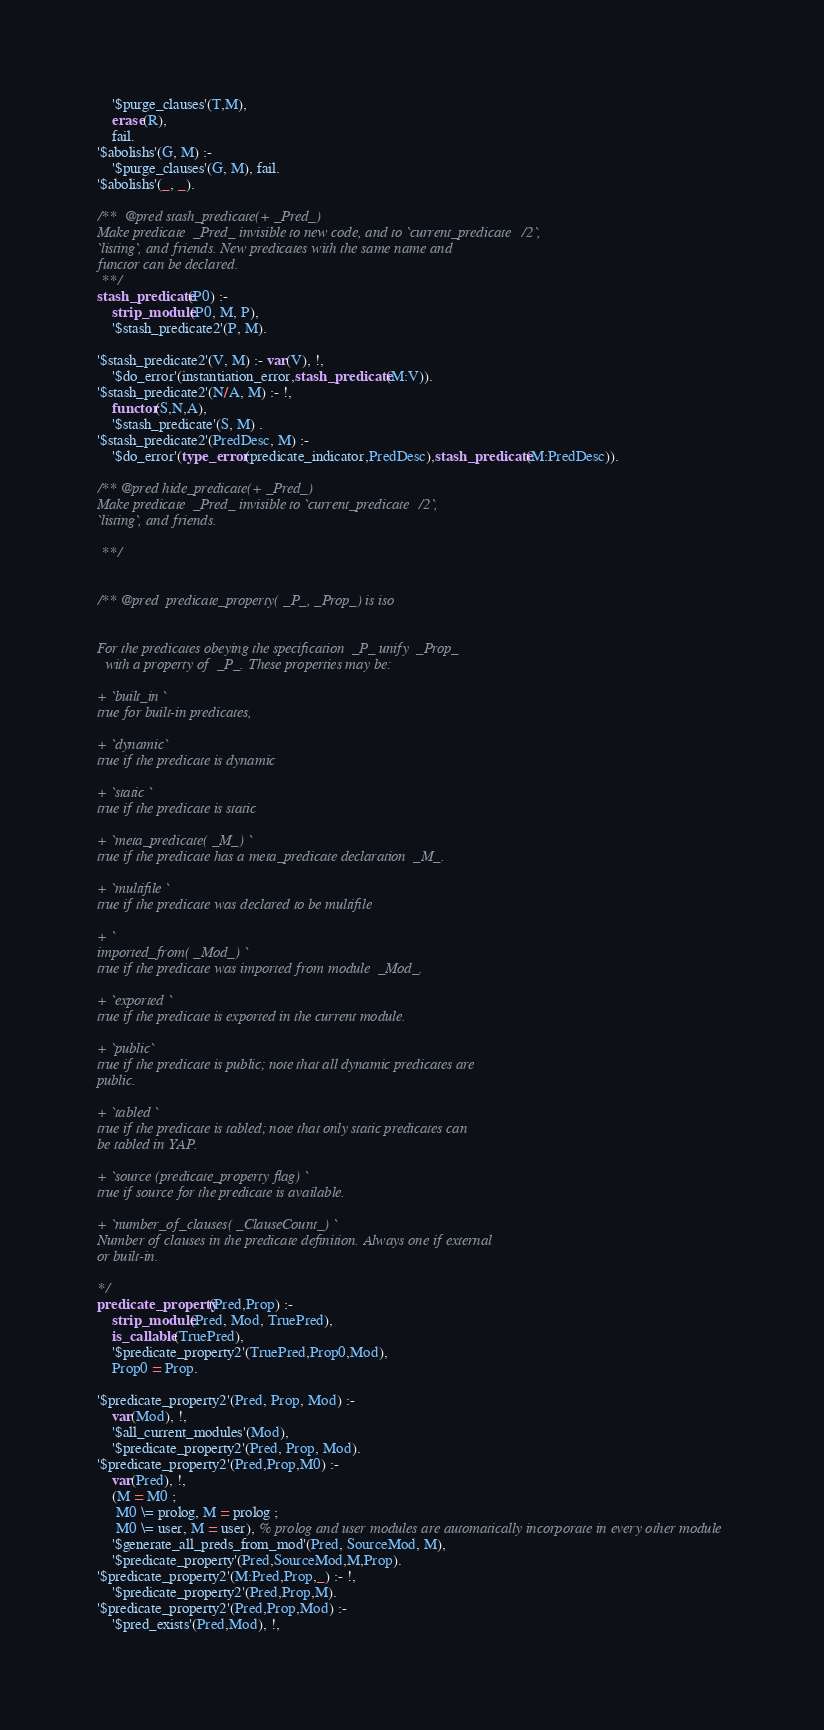<code> <loc_0><loc_0><loc_500><loc_500><_Prolog_>	'$purge_clauses'(T,M),
	erase(R),
	fail.
'$abolishs'(G, M) :-
	'$purge_clauses'(G, M), fail.
'$abolishs'(_, _).

/**  @pred stash_predicate(+ _Pred_)
Make predicate  _Pred_ invisible to new code, and to `current_predicate/2`,
`listing`, and friends. New predicates with the same name and
functor can be declared.
 **/
stash_predicate(P0) :-
	strip_module(P0, M, P),
	'$stash_predicate2'(P, M).

'$stash_predicate2'(V, M) :- var(V), !,
	'$do_error'(instantiation_error,stash_predicate(M:V)).
'$stash_predicate2'(N/A, M) :- !,
	functor(S,N,A),
	'$stash_predicate'(S, M) .
'$stash_predicate2'(PredDesc, M) :-
	'$do_error'(type_error(predicate_indicator,PredDesc),stash_predicate(M:PredDesc)).

/** @pred hide_predicate(+ _Pred_)
Make predicate  _Pred_ invisible to `current_predicate/2`,
`listing`, and friends.

 **/


/** @pred  predicate_property( _P_, _Prop_) is iso


For the predicates obeying the specification  _P_ unify  _Prop_
  with a property of  _P_. These properties may be:

+ `built_in `
true for built-in predicates,

+ `dynamic`
true if the predicate is dynamic

+ `static `
true if the predicate is static

+ `meta_predicate( _M_) `
true if the predicate has a meta_predicate declaration  _M_.

+ `multifile `
true if the predicate was declared to be multifile

+ `
imported_from( _Mod_) `
true if the predicate was imported from module  _Mod_.

+ `exported `
true if the predicate is exported in the current module.

+ `public`
true if the predicate is public; note that all dynamic predicates are
public.

+ `tabled `
true if the predicate is tabled; note that only static predicates can
be tabled in YAP.

+ `source (predicate_property flag) `
true if source for the predicate is available.

+ `number_of_clauses( _ClauseCount_) `
Number of clauses in the predicate definition. Always one if external
or built-in.

*/
predicate_property(Pred,Prop) :-
    strip_module(Pred, Mod, TruePred),
    is_callable(TruePred),
    '$predicate_property2'(TruePred,Prop0,Mod),
    Prop0 = Prop.

'$predicate_property2'(Pred, Prop, Mod) :-
	var(Mod), !,
	'$all_current_modules'(Mod),
	'$predicate_property2'(Pred, Prop, Mod).
'$predicate_property2'(Pred,Prop,M0) :-
	var(Pred), !,
	(M = M0 ;
	 M0 \= prolog, M = prolog ;
	 M0 \= user, M = user), % prolog and user modules are automatically incorporate in every other module
	'$generate_all_preds_from_mod'(Pred, SourceMod, M),
	'$predicate_property'(Pred,SourceMod,M,Prop).
'$predicate_property2'(M:Pred,Prop,_) :- !,
	'$predicate_property2'(Pred,Prop,M).
'$predicate_property2'(Pred,Prop,Mod) :-
	'$pred_exists'(Pred,Mod), !,</code> 